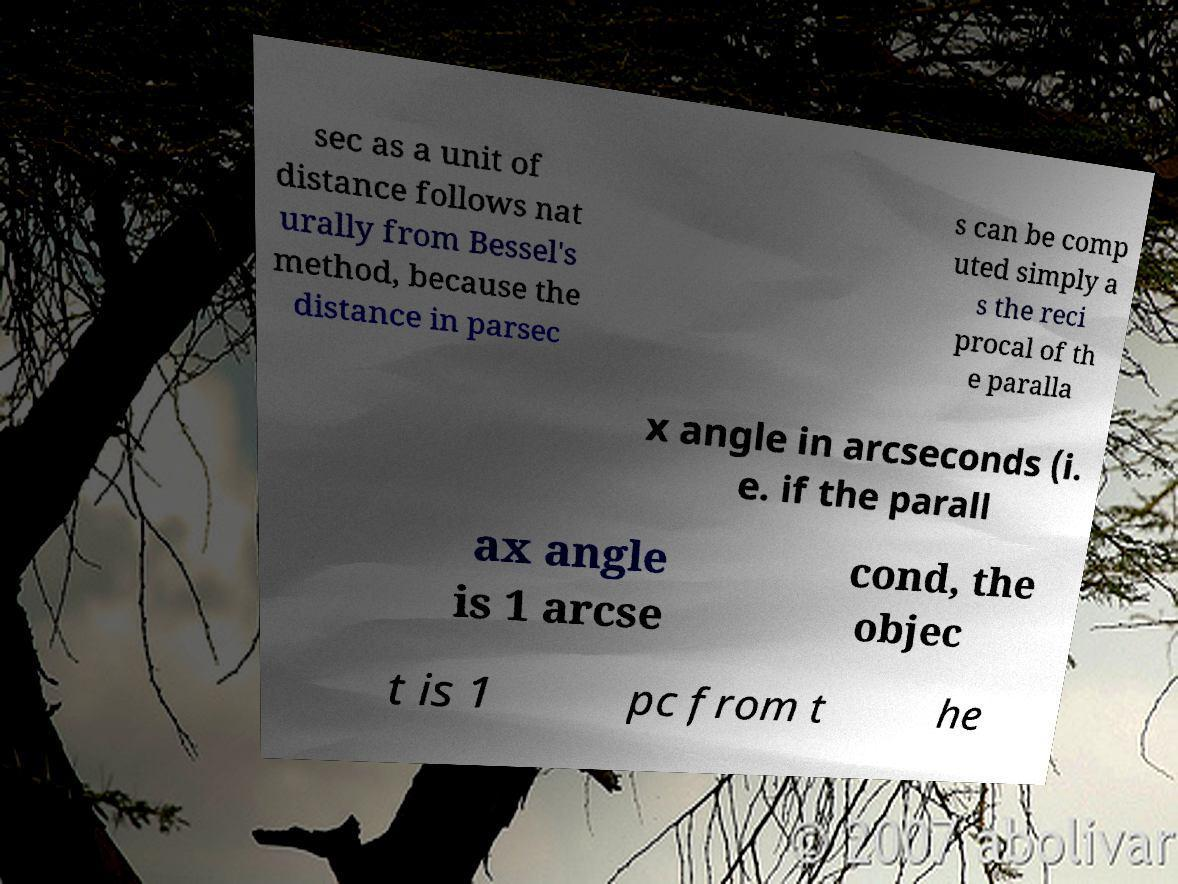There's text embedded in this image that I need extracted. Can you transcribe it verbatim? sec as a unit of distance follows nat urally from Bessel's method, because the distance in parsec s can be comp uted simply a s the reci procal of th e paralla x angle in arcseconds (i. e. if the parall ax angle is 1 arcse cond, the objec t is 1 pc from t he 